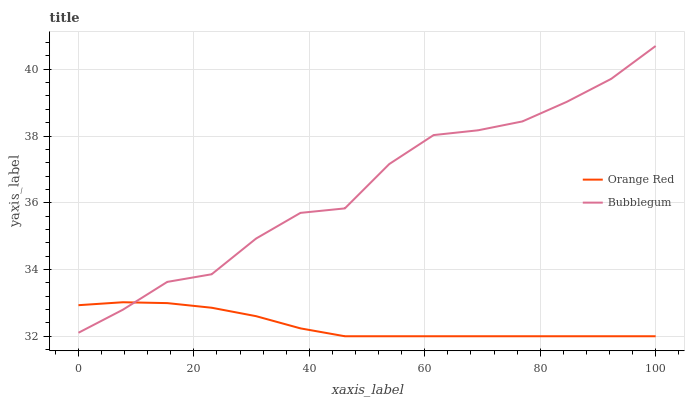Does Orange Red have the minimum area under the curve?
Answer yes or no. Yes. Does Bubblegum have the maximum area under the curve?
Answer yes or no. Yes. Does Bubblegum have the minimum area under the curve?
Answer yes or no. No. Is Orange Red the smoothest?
Answer yes or no. Yes. Is Bubblegum the roughest?
Answer yes or no. Yes. Is Bubblegum the smoothest?
Answer yes or no. No. Does Bubblegum have the lowest value?
Answer yes or no. No. Does Bubblegum have the highest value?
Answer yes or no. Yes. 